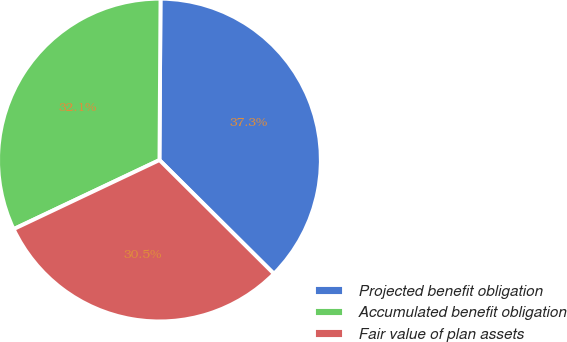Convert chart. <chart><loc_0><loc_0><loc_500><loc_500><pie_chart><fcel>Projected benefit obligation<fcel>Accumulated benefit obligation<fcel>Fair value of plan assets<nl><fcel>37.34%<fcel>32.14%<fcel>30.51%<nl></chart> 